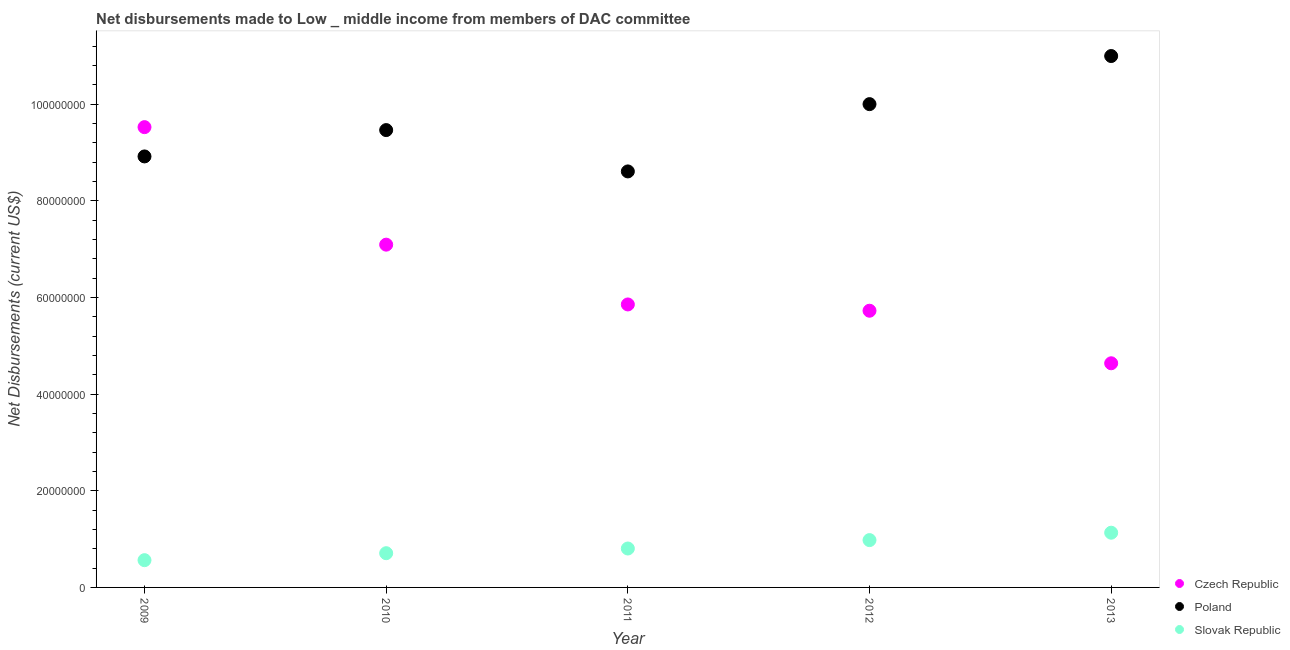Is the number of dotlines equal to the number of legend labels?
Keep it short and to the point. Yes. What is the net disbursements made by czech republic in 2011?
Offer a very short reply. 5.85e+07. Across all years, what is the maximum net disbursements made by czech republic?
Provide a short and direct response. 9.52e+07. Across all years, what is the minimum net disbursements made by poland?
Ensure brevity in your answer.  8.61e+07. In which year was the net disbursements made by czech republic maximum?
Offer a very short reply. 2009. What is the total net disbursements made by czech republic in the graph?
Offer a very short reply. 3.28e+08. What is the difference between the net disbursements made by slovak republic in 2009 and that in 2011?
Make the answer very short. -2.41e+06. What is the difference between the net disbursements made by poland in 2011 and the net disbursements made by slovak republic in 2013?
Your answer should be very brief. 7.47e+07. What is the average net disbursements made by poland per year?
Ensure brevity in your answer.  9.59e+07. In the year 2010, what is the difference between the net disbursements made by czech republic and net disbursements made by poland?
Your answer should be very brief. -2.37e+07. In how many years, is the net disbursements made by czech republic greater than 92000000 US$?
Your answer should be very brief. 1. What is the ratio of the net disbursements made by slovak republic in 2010 to that in 2013?
Offer a terse response. 0.63. Is the difference between the net disbursements made by poland in 2009 and 2010 greater than the difference between the net disbursements made by czech republic in 2009 and 2010?
Make the answer very short. No. What is the difference between the highest and the second highest net disbursements made by slovak republic?
Offer a terse response. 1.53e+06. What is the difference between the highest and the lowest net disbursements made by slovak republic?
Provide a succinct answer. 5.68e+06. Does the net disbursements made by slovak republic monotonically increase over the years?
Your answer should be compact. Yes. What is the difference between two consecutive major ticks on the Y-axis?
Your response must be concise. 2.00e+07. Does the graph contain grids?
Ensure brevity in your answer.  No. Where does the legend appear in the graph?
Your answer should be very brief. Bottom right. How many legend labels are there?
Keep it short and to the point. 3. What is the title of the graph?
Your answer should be very brief. Net disbursements made to Low _ middle income from members of DAC committee. Does "Domestic" appear as one of the legend labels in the graph?
Your response must be concise. No. What is the label or title of the Y-axis?
Your response must be concise. Net Disbursements (current US$). What is the Net Disbursements (current US$) in Czech Republic in 2009?
Ensure brevity in your answer.  9.52e+07. What is the Net Disbursements (current US$) in Poland in 2009?
Your answer should be very brief. 8.92e+07. What is the Net Disbursements (current US$) of Slovak Republic in 2009?
Your answer should be very brief. 5.64e+06. What is the Net Disbursements (current US$) in Czech Republic in 2010?
Give a very brief answer. 7.09e+07. What is the Net Disbursements (current US$) of Poland in 2010?
Your answer should be compact. 9.46e+07. What is the Net Disbursements (current US$) in Slovak Republic in 2010?
Your answer should be compact. 7.08e+06. What is the Net Disbursements (current US$) in Czech Republic in 2011?
Keep it short and to the point. 5.85e+07. What is the Net Disbursements (current US$) in Poland in 2011?
Offer a terse response. 8.61e+07. What is the Net Disbursements (current US$) of Slovak Republic in 2011?
Your answer should be compact. 8.05e+06. What is the Net Disbursements (current US$) in Czech Republic in 2012?
Make the answer very short. 5.72e+07. What is the Net Disbursements (current US$) in Poland in 2012?
Offer a very short reply. 1.00e+08. What is the Net Disbursements (current US$) in Slovak Republic in 2012?
Your response must be concise. 9.79e+06. What is the Net Disbursements (current US$) of Czech Republic in 2013?
Your answer should be very brief. 4.64e+07. What is the Net Disbursements (current US$) of Poland in 2013?
Offer a terse response. 1.10e+08. What is the Net Disbursements (current US$) in Slovak Republic in 2013?
Make the answer very short. 1.13e+07. Across all years, what is the maximum Net Disbursements (current US$) of Czech Republic?
Keep it short and to the point. 9.52e+07. Across all years, what is the maximum Net Disbursements (current US$) in Poland?
Make the answer very short. 1.10e+08. Across all years, what is the maximum Net Disbursements (current US$) of Slovak Republic?
Keep it short and to the point. 1.13e+07. Across all years, what is the minimum Net Disbursements (current US$) in Czech Republic?
Your response must be concise. 4.64e+07. Across all years, what is the minimum Net Disbursements (current US$) in Poland?
Your answer should be compact. 8.61e+07. Across all years, what is the minimum Net Disbursements (current US$) in Slovak Republic?
Provide a succinct answer. 5.64e+06. What is the total Net Disbursements (current US$) of Czech Republic in the graph?
Your answer should be compact. 3.28e+08. What is the total Net Disbursements (current US$) of Poland in the graph?
Keep it short and to the point. 4.80e+08. What is the total Net Disbursements (current US$) in Slovak Republic in the graph?
Your answer should be very brief. 4.19e+07. What is the difference between the Net Disbursements (current US$) in Czech Republic in 2009 and that in 2010?
Ensure brevity in your answer.  2.43e+07. What is the difference between the Net Disbursements (current US$) of Poland in 2009 and that in 2010?
Offer a terse response. -5.45e+06. What is the difference between the Net Disbursements (current US$) of Slovak Republic in 2009 and that in 2010?
Offer a terse response. -1.44e+06. What is the difference between the Net Disbursements (current US$) in Czech Republic in 2009 and that in 2011?
Your answer should be very brief. 3.67e+07. What is the difference between the Net Disbursements (current US$) of Poland in 2009 and that in 2011?
Give a very brief answer. 3.10e+06. What is the difference between the Net Disbursements (current US$) of Slovak Republic in 2009 and that in 2011?
Make the answer very short. -2.41e+06. What is the difference between the Net Disbursements (current US$) of Czech Republic in 2009 and that in 2012?
Provide a succinct answer. 3.80e+07. What is the difference between the Net Disbursements (current US$) in Poland in 2009 and that in 2012?
Make the answer very short. -1.08e+07. What is the difference between the Net Disbursements (current US$) of Slovak Republic in 2009 and that in 2012?
Your answer should be compact. -4.15e+06. What is the difference between the Net Disbursements (current US$) in Czech Republic in 2009 and that in 2013?
Ensure brevity in your answer.  4.88e+07. What is the difference between the Net Disbursements (current US$) of Poland in 2009 and that in 2013?
Make the answer very short. -2.08e+07. What is the difference between the Net Disbursements (current US$) of Slovak Republic in 2009 and that in 2013?
Your answer should be very brief. -5.68e+06. What is the difference between the Net Disbursements (current US$) of Czech Republic in 2010 and that in 2011?
Offer a very short reply. 1.24e+07. What is the difference between the Net Disbursements (current US$) in Poland in 2010 and that in 2011?
Your answer should be very brief. 8.55e+06. What is the difference between the Net Disbursements (current US$) in Slovak Republic in 2010 and that in 2011?
Offer a very short reply. -9.70e+05. What is the difference between the Net Disbursements (current US$) of Czech Republic in 2010 and that in 2012?
Provide a succinct answer. 1.37e+07. What is the difference between the Net Disbursements (current US$) in Poland in 2010 and that in 2012?
Your answer should be compact. -5.37e+06. What is the difference between the Net Disbursements (current US$) of Slovak Republic in 2010 and that in 2012?
Provide a succinct answer. -2.71e+06. What is the difference between the Net Disbursements (current US$) of Czech Republic in 2010 and that in 2013?
Your answer should be compact. 2.45e+07. What is the difference between the Net Disbursements (current US$) of Poland in 2010 and that in 2013?
Provide a succinct answer. -1.53e+07. What is the difference between the Net Disbursements (current US$) in Slovak Republic in 2010 and that in 2013?
Offer a terse response. -4.24e+06. What is the difference between the Net Disbursements (current US$) of Czech Republic in 2011 and that in 2012?
Your answer should be very brief. 1.30e+06. What is the difference between the Net Disbursements (current US$) in Poland in 2011 and that in 2012?
Your answer should be very brief. -1.39e+07. What is the difference between the Net Disbursements (current US$) of Slovak Republic in 2011 and that in 2012?
Offer a very short reply. -1.74e+06. What is the difference between the Net Disbursements (current US$) of Czech Republic in 2011 and that in 2013?
Your answer should be compact. 1.22e+07. What is the difference between the Net Disbursements (current US$) of Poland in 2011 and that in 2013?
Provide a succinct answer. -2.39e+07. What is the difference between the Net Disbursements (current US$) in Slovak Republic in 2011 and that in 2013?
Make the answer very short. -3.27e+06. What is the difference between the Net Disbursements (current US$) in Czech Republic in 2012 and that in 2013?
Give a very brief answer. 1.09e+07. What is the difference between the Net Disbursements (current US$) of Poland in 2012 and that in 2013?
Keep it short and to the point. -9.95e+06. What is the difference between the Net Disbursements (current US$) in Slovak Republic in 2012 and that in 2013?
Give a very brief answer. -1.53e+06. What is the difference between the Net Disbursements (current US$) in Czech Republic in 2009 and the Net Disbursements (current US$) in Slovak Republic in 2010?
Give a very brief answer. 8.81e+07. What is the difference between the Net Disbursements (current US$) in Poland in 2009 and the Net Disbursements (current US$) in Slovak Republic in 2010?
Your answer should be compact. 8.21e+07. What is the difference between the Net Disbursements (current US$) of Czech Republic in 2009 and the Net Disbursements (current US$) of Poland in 2011?
Your response must be concise. 9.16e+06. What is the difference between the Net Disbursements (current US$) of Czech Republic in 2009 and the Net Disbursements (current US$) of Slovak Republic in 2011?
Ensure brevity in your answer.  8.72e+07. What is the difference between the Net Disbursements (current US$) in Poland in 2009 and the Net Disbursements (current US$) in Slovak Republic in 2011?
Your response must be concise. 8.11e+07. What is the difference between the Net Disbursements (current US$) of Czech Republic in 2009 and the Net Disbursements (current US$) of Poland in 2012?
Make the answer very short. -4.76e+06. What is the difference between the Net Disbursements (current US$) of Czech Republic in 2009 and the Net Disbursements (current US$) of Slovak Republic in 2012?
Make the answer very short. 8.54e+07. What is the difference between the Net Disbursements (current US$) in Poland in 2009 and the Net Disbursements (current US$) in Slovak Republic in 2012?
Your answer should be compact. 7.94e+07. What is the difference between the Net Disbursements (current US$) of Czech Republic in 2009 and the Net Disbursements (current US$) of Poland in 2013?
Give a very brief answer. -1.47e+07. What is the difference between the Net Disbursements (current US$) in Czech Republic in 2009 and the Net Disbursements (current US$) in Slovak Republic in 2013?
Provide a succinct answer. 8.39e+07. What is the difference between the Net Disbursements (current US$) in Poland in 2009 and the Net Disbursements (current US$) in Slovak Republic in 2013?
Provide a succinct answer. 7.78e+07. What is the difference between the Net Disbursements (current US$) in Czech Republic in 2010 and the Net Disbursements (current US$) in Poland in 2011?
Give a very brief answer. -1.52e+07. What is the difference between the Net Disbursements (current US$) in Czech Republic in 2010 and the Net Disbursements (current US$) in Slovak Republic in 2011?
Your response must be concise. 6.29e+07. What is the difference between the Net Disbursements (current US$) in Poland in 2010 and the Net Disbursements (current US$) in Slovak Republic in 2011?
Give a very brief answer. 8.66e+07. What is the difference between the Net Disbursements (current US$) of Czech Republic in 2010 and the Net Disbursements (current US$) of Poland in 2012?
Provide a short and direct response. -2.91e+07. What is the difference between the Net Disbursements (current US$) of Czech Republic in 2010 and the Net Disbursements (current US$) of Slovak Republic in 2012?
Keep it short and to the point. 6.11e+07. What is the difference between the Net Disbursements (current US$) of Poland in 2010 and the Net Disbursements (current US$) of Slovak Republic in 2012?
Make the answer very short. 8.48e+07. What is the difference between the Net Disbursements (current US$) in Czech Republic in 2010 and the Net Disbursements (current US$) in Poland in 2013?
Your answer should be compact. -3.90e+07. What is the difference between the Net Disbursements (current US$) in Czech Republic in 2010 and the Net Disbursements (current US$) in Slovak Republic in 2013?
Offer a terse response. 5.96e+07. What is the difference between the Net Disbursements (current US$) of Poland in 2010 and the Net Disbursements (current US$) of Slovak Republic in 2013?
Your response must be concise. 8.33e+07. What is the difference between the Net Disbursements (current US$) of Czech Republic in 2011 and the Net Disbursements (current US$) of Poland in 2012?
Offer a very short reply. -4.14e+07. What is the difference between the Net Disbursements (current US$) in Czech Republic in 2011 and the Net Disbursements (current US$) in Slovak Republic in 2012?
Offer a very short reply. 4.88e+07. What is the difference between the Net Disbursements (current US$) in Poland in 2011 and the Net Disbursements (current US$) in Slovak Republic in 2012?
Your response must be concise. 7.63e+07. What is the difference between the Net Disbursements (current US$) in Czech Republic in 2011 and the Net Disbursements (current US$) in Poland in 2013?
Give a very brief answer. -5.14e+07. What is the difference between the Net Disbursements (current US$) in Czech Republic in 2011 and the Net Disbursements (current US$) in Slovak Republic in 2013?
Your answer should be very brief. 4.72e+07. What is the difference between the Net Disbursements (current US$) of Poland in 2011 and the Net Disbursements (current US$) of Slovak Republic in 2013?
Keep it short and to the point. 7.47e+07. What is the difference between the Net Disbursements (current US$) of Czech Republic in 2012 and the Net Disbursements (current US$) of Poland in 2013?
Provide a short and direct response. -5.27e+07. What is the difference between the Net Disbursements (current US$) in Czech Republic in 2012 and the Net Disbursements (current US$) in Slovak Republic in 2013?
Your answer should be compact. 4.59e+07. What is the difference between the Net Disbursements (current US$) in Poland in 2012 and the Net Disbursements (current US$) in Slovak Republic in 2013?
Provide a succinct answer. 8.87e+07. What is the average Net Disbursements (current US$) in Czech Republic per year?
Keep it short and to the point. 6.57e+07. What is the average Net Disbursements (current US$) of Poland per year?
Provide a succinct answer. 9.59e+07. What is the average Net Disbursements (current US$) in Slovak Republic per year?
Keep it short and to the point. 8.38e+06. In the year 2009, what is the difference between the Net Disbursements (current US$) in Czech Republic and Net Disbursements (current US$) in Poland?
Make the answer very short. 6.06e+06. In the year 2009, what is the difference between the Net Disbursements (current US$) in Czech Republic and Net Disbursements (current US$) in Slovak Republic?
Offer a terse response. 8.96e+07. In the year 2009, what is the difference between the Net Disbursements (current US$) of Poland and Net Disbursements (current US$) of Slovak Republic?
Provide a succinct answer. 8.35e+07. In the year 2010, what is the difference between the Net Disbursements (current US$) of Czech Republic and Net Disbursements (current US$) of Poland?
Offer a terse response. -2.37e+07. In the year 2010, what is the difference between the Net Disbursements (current US$) in Czech Republic and Net Disbursements (current US$) in Slovak Republic?
Give a very brief answer. 6.38e+07. In the year 2010, what is the difference between the Net Disbursements (current US$) of Poland and Net Disbursements (current US$) of Slovak Republic?
Provide a succinct answer. 8.75e+07. In the year 2011, what is the difference between the Net Disbursements (current US$) of Czech Republic and Net Disbursements (current US$) of Poland?
Keep it short and to the point. -2.75e+07. In the year 2011, what is the difference between the Net Disbursements (current US$) of Czech Republic and Net Disbursements (current US$) of Slovak Republic?
Give a very brief answer. 5.05e+07. In the year 2011, what is the difference between the Net Disbursements (current US$) of Poland and Net Disbursements (current US$) of Slovak Republic?
Ensure brevity in your answer.  7.80e+07. In the year 2012, what is the difference between the Net Disbursements (current US$) of Czech Republic and Net Disbursements (current US$) of Poland?
Your answer should be compact. -4.27e+07. In the year 2012, what is the difference between the Net Disbursements (current US$) of Czech Republic and Net Disbursements (current US$) of Slovak Republic?
Make the answer very short. 4.74e+07. In the year 2012, what is the difference between the Net Disbursements (current US$) in Poland and Net Disbursements (current US$) in Slovak Republic?
Provide a short and direct response. 9.02e+07. In the year 2013, what is the difference between the Net Disbursements (current US$) of Czech Republic and Net Disbursements (current US$) of Poland?
Make the answer very short. -6.36e+07. In the year 2013, what is the difference between the Net Disbursements (current US$) of Czech Republic and Net Disbursements (current US$) of Slovak Republic?
Keep it short and to the point. 3.50e+07. In the year 2013, what is the difference between the Net Disbursements (current US$) in Poland and Net Disbursements (current US$) in Slovak Republic?
Your answer should be very brief. 9.86e+07. What is the ratio of the Net Disbursements (current US$) of Czech Republic in 2009 to that in 2010?
Provide a short and direct response. 1.34. What is the ratio of the Net Disbursements (current US$) of Poland in 2009 to that in 2010?
Give a very brief answer. 0.94. What is the ratio of the Net Disbursements (current US$) of Slovak Republic in 2009 to that in 2010?
Keep it short and to the point. 0.8. What is the ratio of the Net Disbursements (current US$) of Czech Republic in 2009 to that in 2011?
Provide a succinct answer. 1.63. What is the ratio of the Net Disbursements (current US$) of Poland in 2009 to that in 2011?
Your answer should be compact. 1.04. What is the ratio of the Net Disbursements (current US$) in Slovak Republic in 2009 to that in 2011?
Your response must be concise. 0.7. What is the ratio of the Net Disbursements (current US$) of Czech Republic in 2009 to that in 2012?
Provide a short and direct response. 1.66. What is the ratio of the Net Disbursements (current US$) of Poland in 2009 to that in 2012?
Offer a very short reply. 0.89. What is the ratio of the Net Disbursements (current US$) in Slovak Republic in 2009 to that in 2012?
Your answer should be compact. 0.58. What is the ratio of the Net Disbursements (current US$) in Czech Republic in 2009 to that in 2013?
Your answer should be compact. 2.05. What is the ratio of the Net Disbursements (current US$) of Poland in 2009 to that in 2013?
Provide a succinct answer. 0.81. What is the ratio of the Net Disbursements (current US$) in Slovak Republic in 2009 to that in 2013?
Offer a very short reply. 0.5. What is the ratio of the Net Disbursements (current US$) of Czech Republic in 2010 to that in 2011?
Offer a terse response. 1.21. What is the ratio of the Net Disbursements (current US$) of Poland in 2010 to that in 2011?
Your answer should be compact. 1.1. What is the ratio of the Net Disbursements (current US$) of Slovak Republic in 2010 to that in 2011?
Offer a terse response. 0.88. What is the ratio of the Net Disbursements (current US$) in Czech Republic in 2010 to that in 2012?
Offer a very short reply. 1.24. What is the ratio of the Net Disbursements (current US$) in Poland in 2010 to that in 2012?
Keep it short and to the point. 0.95. What is the ratio of the Net Disbursements (current US$) in Slovak Republic in 2010 to that in 2012?
Provide a succinct answer. 0.72. What is the ratio of the Net Disbursements (current US$) in Czech Republic in 2010 to that in 2013?
Offer a very short reply. 1.53. What is the ratio of the Net Disbursements (current US$) of Poland in 2010 to that in 2013?
Provide a succinct answer. 0.86. What is the ratio of the Net Disbursements (current US$) of Slovak Republic in 2010 to that in 2013?
Your answer should be very brief. 0.63. What is the ratio of the Net Disbursements (current US$) of Czech Republic in 2011 to that in 2012?
Make the answer very short. 1.02. What is the ratio of the Net Disbursements (current US$) in Poland in 2011 to that in 2012?
Offer a very short reply. 0.86. What is the ratio of the Net Disbursements (current US$) in Slovak Republic in 2011 to that in 2012?
Keep it short and to the point. 0.82. What is the ratio of the Net Disbursements (current US$) in Czech Republic in 2011 to that in 2013?
Ensure brevity in your answer.  1.26. What is the ratio of the Net Disbursements (current US$) of Poland in 2011 to that in 2013?
Provide a short and direct response. 0.78. What is the ratio of the Net Disbursements (current US$) of Slovak Republic in 2011 to that in 2013?
Provide a short and direct response. 0.71. What is the ratio of the Net Disbursements (current US$) of Czech Republic in 2012 to that in 2013?
Provide a short and direct response. 1.23. What is the ratio of the Net Disbursements (current US$) of Poland in 2012 to that in 2013?
Your response must be concise. 0.91. What is the ratio of the Net Disbursements (current US$) of Slovak Republic in 2012 to that in 2013?
Ensure brevity in your answer.  0.86. What is the difference between the highest and the second highest Net Disbursements (current US$) of Czech Republic?
Keep it short and to the point. 2.43e+07. What is the difference between the highest and the second highest Net Disbursements (current US$) in Poland?
Your response must be concise. 9.95e+06. What is the difference between the highest and the second highest Net Disbursements (current US$) of Slovak Republic?
Provide a succinct answer. 1.53e+06. What is the difference between the highest and the lowest Net Disbursements (current US$) of Czech Republic?
Provide a succinct answer. 4.88e+07. What is the difference between the highest and the lowest Net Disbursements (current US$) in Poland?
Provide a short and direct response. 2.39e+07. What is the difference between the highest and the lowest Net Disbursements (current US$) in Slovak Republic?
Keep it short and to the point. 5.68e+06. 